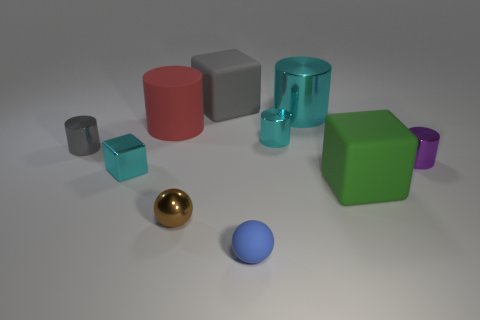There is a big thing that is the same color as the tiny metallic cube; what shape is it?
Your answer should be very brief. Cylinder. What color is the large rubber cube that is in front of the large cube behind the purple shiny cylinder?
Your response must be concise. Green. Are any purple objects visible?
Provide a short and direct response. Yes. There is a cube that is both in front of the large cyan cylinder and on the right side of the cyan cube; what is its color?
Your response must be concise. Green. There is a matte cube behind the green rubber object; is its size the same as the metallic thing that is behind the small cyan metallic cylinder?
Provide a succinct answer. Yes. How many other things are the same size as the green rubber thing?
Give a very brief answer. 3. What number of shiny balls are behind the small cyan thing that is in front of the gray cylinder?
Provide a succinct answer. 0. Is the number of cyan things in front of the large green cube less than the number of small gray metal cylinders?
Provide a succinct answer. Yes. There is a cyan shiny object that is in front of the tiny gray thing that is on the left side of the gray rubber object that is behind the green cube; what shape is it?
Offer a very short reply. Cube. Is the green matte object the same shape as the blue matte object?
Provide a succinct answer. No. 